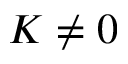<formula> <loc_0><loc_0><loc_500><loc_500>K \neq 0</formula> 